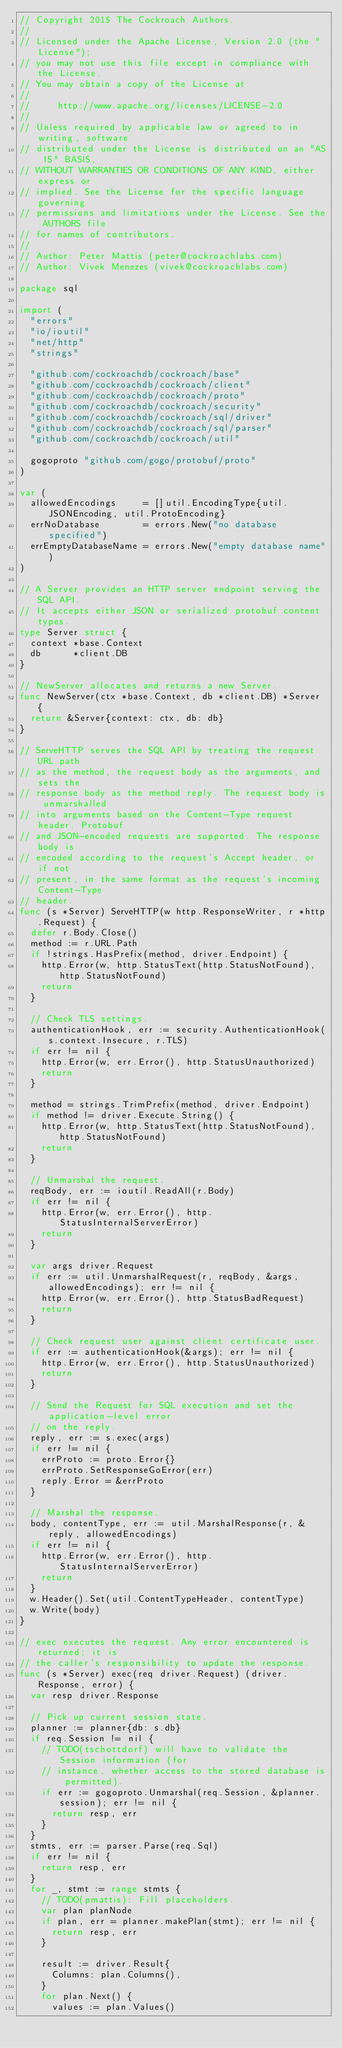Convert code to text. <code><loc_0><loc_0><loc_500><loc_500><_Go_>// Copyright 2015 The Cockroach Authors.
//
// Licensed under the Apache License, Version 2.0 (the "License");
// you may not use this file except in compliance with the License.
// You may obtain a copy of the License at
//
//     http://www.apache.org/licenses/LICENSE-2.0
//
// Unless required by applicable law or agreed to in writing, software
// distributed under the License is distributed on an "AS IS" BASIS,
// WITHOUT WARRANTIES OR CONDITIONS OF ANY KIND, either express or
// implied. See the License for the specific language governing
// permissions and limitations under the License. See the AUTHORS file
// for names of contributors.
//
// Author: Peter Mattis (peter@cockroachlabs.com)
// Author: Vivek Menezes (vivek@cockroachlabs.com)

package sql

import (
	"errors"
	"io/ioutil"
	"net/http"
	"strings"

	"github.com/cockroachdb/cockroach/base"
	"github.com/cockroachdb/cockroach/client"
	"github.com/cockroachdb/cockroach/proto"
	"github.com/cockroachdb/cockroach/security"
	"github.com/cockroachdb/cockroach/sql/driver"
	"github.com/cockroachdb/cockroach/sql/parser"
	"github.com/cockroachdb/cockroach/util"

	gogoproto "github.com/gogo/protobuf/proto"
)

var (
	allowedEncodings     = []util.EncodingType{util.JSONEncoding, util.ProtoEncoding}
	errNoDatabase        = errors.New("no database specified")
	errEmptyDatabaseName = errors.New("empty database name")
)

// A Server provides an HTTP server endpoint serving the SQL API.
// It accepts either JSON or serialized protobuf content types.
type Server struct {
	context *base.Context
	db      *client.DB
}

// NewServer allocates and returns a new Server.
func NewServer(ctx *base.Context, db *client.DB) *Server {
	return &Server{context: ctx, db: db}
}

// ServeHTTP serves the SQL API by treating the request URL path
// as the method, the request body as the arguments, and sets the
// response body as the method reply. The request body is unmarshalled
// into arguments based on the Content-Type request header. Protobuf
// and JSON-encoded requests are supported. The response body is
// encoded according to the request's Accept header, or if not
// present, in the same format as the request's incoming Content-Type
// header.
func (s *Server) ServeHTTP(w http.ResponseWriter, r *http.Request) {
	defer r.Body.Close()
	method := r.URL.Path
	if !strings.HasPrefix(method, driver.Endpoint) {
		http.Error(w, http.StatusText(http.StatusNotFound), http.StatusNotFound)
		return
	}

	// Check TLS settings.
	authenticationHook, err := security.AuthenticationHook(s.context.Insecure, r.TLS)
	if err != nil {
		http.Error(w, err.Error(), http.StatusUnauthorized)
		return
	}

	method = strings.TrimPrefix(method, driver.Endpoint)
	if method != driver.Execute.String() {
		http.Error(w, http.StatusText(http.StatusNotFound), http.StatusNotFound)
		return
	}

	// Unmarshal the request.
	reqBody, err := ioutil.ReadAll(r.Body)
	if err != nil {
		http.Error(w, err.Error(), http.StatusInternalServerError)
		return
	}

	var args driver.Request
	if err := util.UnmarshalRequest(r, reqBody, &args, allowedEncodings); err != nil {
		http.Error(w, err.Error(), http.StatusBadRequest)
		return
	}

	// Check request user against client certificate user.
	if err := authenticationHook(&args); err != nil {
		http.Error(w, err.Error(), http.StatusUnauthorized)
		return
	}

	// Send the Request for SQL execution and set the application-level error
	// on the reply.
	reply, err := s.exec(args)
	if err != nil {
		errProto := proto.Error{}
		errProto.SetResponseGoError(err)
		reply.Error = &errProto
	}

	// Marshal the response.
	body, contentType, err := util.MarshalResponse(r, &reply, allowedEncodings)
	if err != nil {
		http.Error(w, err.Error(), http.StatusInternalServerError)
		return
	}
	w.Header().Set(util.ContentTypeHeader, contentType)
	w.Write(body)
}

// exec executes the request. Any error encountered is returned; it is
// the caller's responsibility to update the response.
func (s *Server) exec(req driver.Request) (driver.Response, error) {
	var resp driver.Response

	// Pick up current session state.
	planner := planner{db: s.db}
	if req.Session != nil {
		// TODO(tschottdorf) will have to validate the Session information (for
		// instance, whether access to the stored database is permitted).
		if err := gogoproto.Unmarshal(req.Session, &planner.session); err != nil {
			return resp, err
		}
	}
	stmts, err := parser.Parse(req.Sql)
	if err != nil {
		return resp, err
	}
	for _, stmt := range stmts {
		// TODO(pmattis): Fill placeholders.
		var plan planNode
		if plan, err = planner.makePlan(stmt); err != nil {
			return resp, err
		}

		result := driver.Result{
			Columns: plan.Columns(),
		}
		for plan.Next() {
			values := plan.Values()</code> 